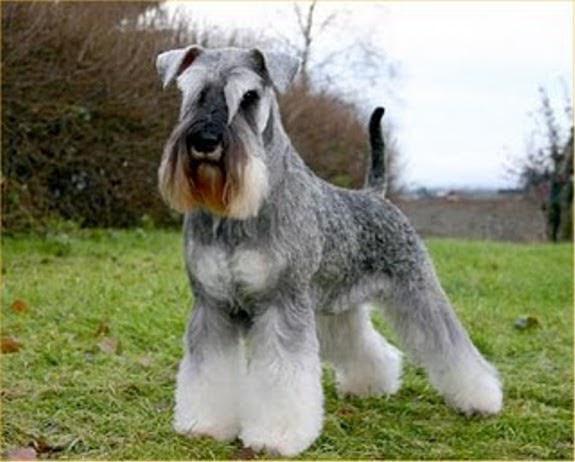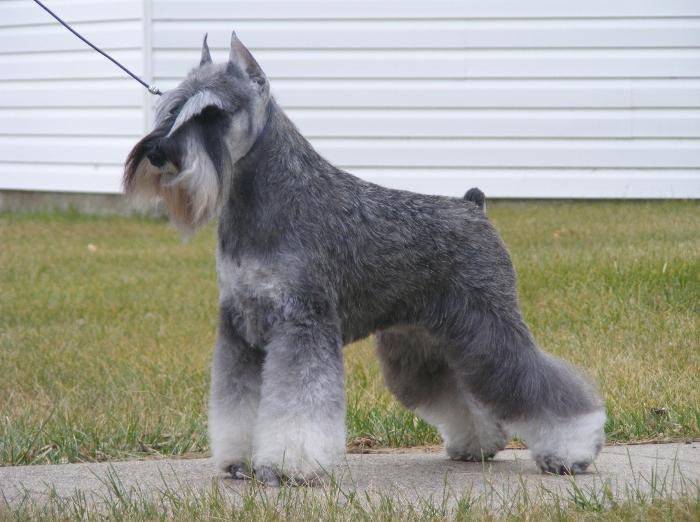The first image is the image on the left, the second image is the image on the right. Considering the images on both sides, is "Right image shows a dog standing outdoors in profile, with body turned leftward." valid? Answer yes or no. Yes. The first image is the image on the left, the second image is the image on the right. For the images displayed, is the sentence "A dog is standing in front of a stone wall." factually correct? Answer yes or no. No. 